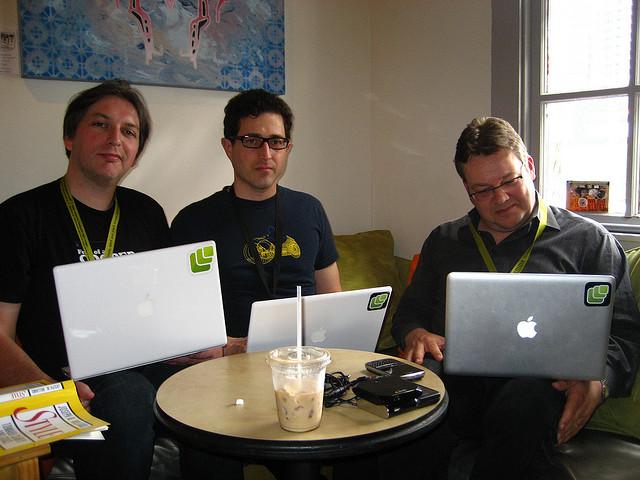Who is the computer manufacturer?
Give a very brief answer. Apple. How many people are in the picture?
Give a very brief answer. 3. Are these men at a computer store?
Give a very brief answer. No. How many laptops?
Short answer required. 3. 